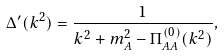Convert formula to latex. <formula><loc_0><loc_0><loc_500><loc_500>\Delta ^ { \prime } ( k ^ { 2 } ) = \frac { 1 } { k ^ { 2 } + m _ { A } ^ { 2 } - \Pi ^ { ( 0 ) } _ { A A } ( k ^ { 2 } ) } ,</formula> 